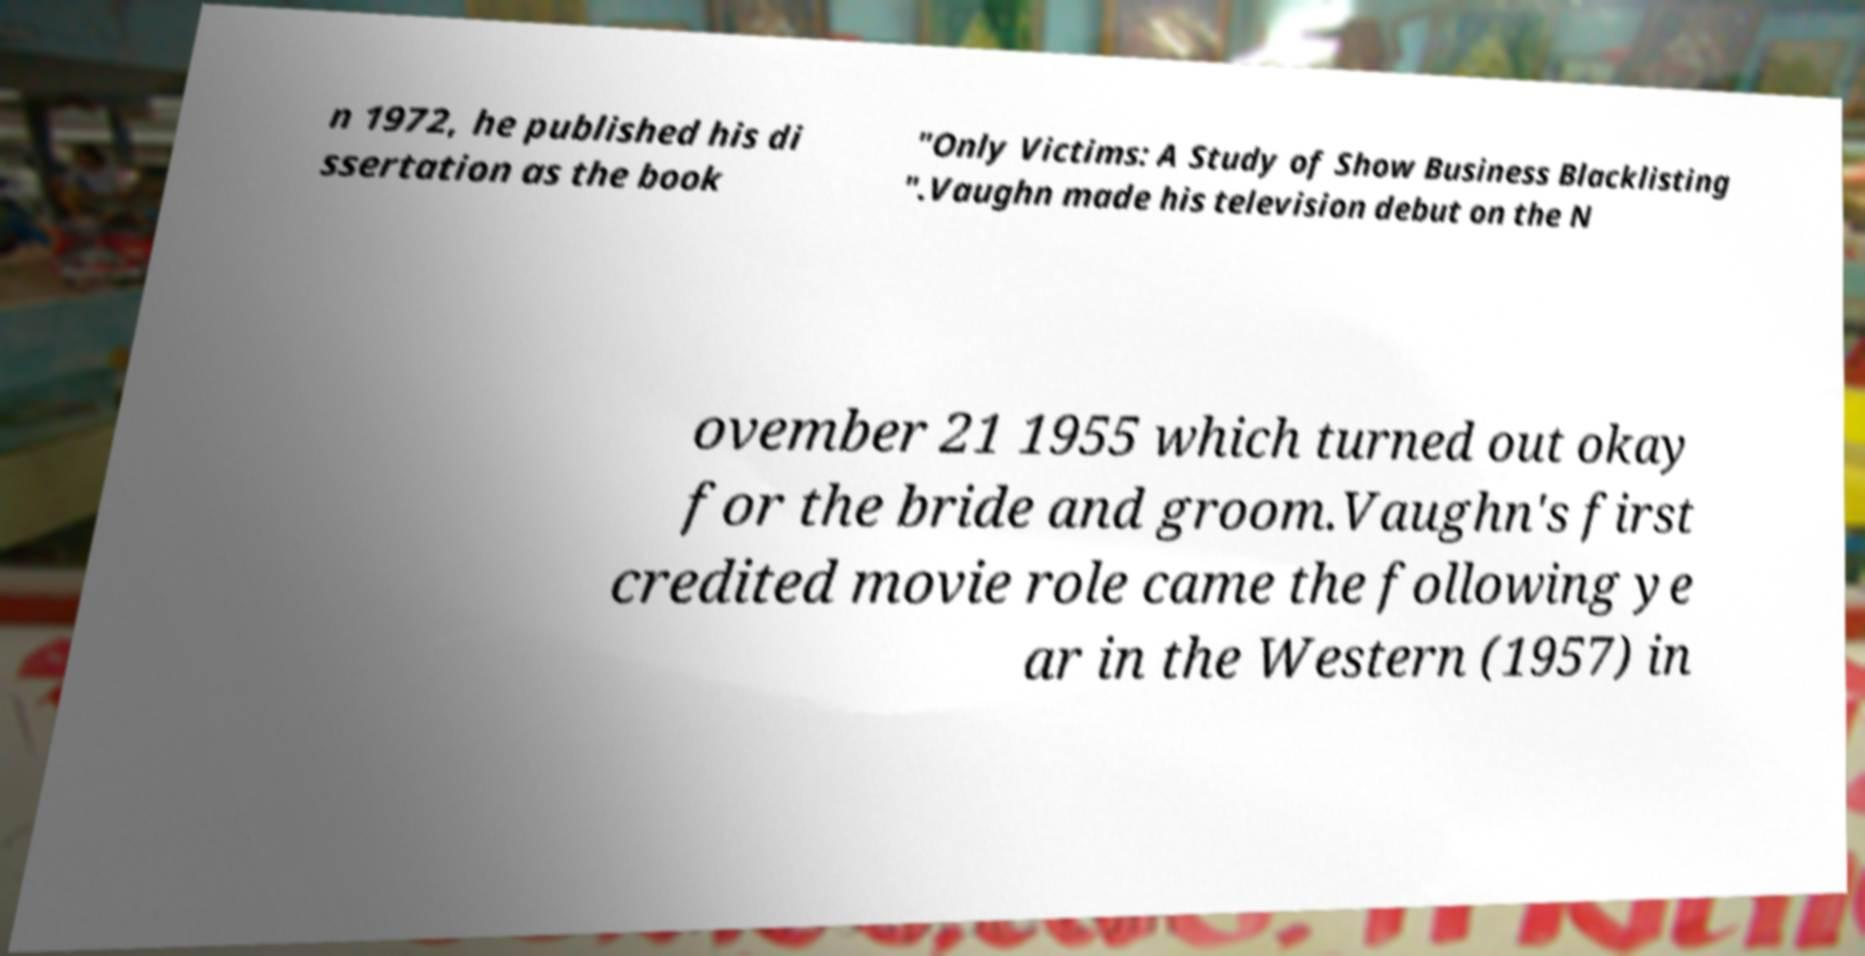Can you read and provide the text displayed in the image?This photo seems to have some interesting text. Can you extract and type it out for me? n 1972, he published his di ssertation as the book "Only Victims: A Study of Show Business Blacklisting ".Vaughn made his television debut on the N ovember 21 1955 which turned out okay for the bride and groom.Vaughn's first credited movie role came the following ye ar in the Western (1957) in 